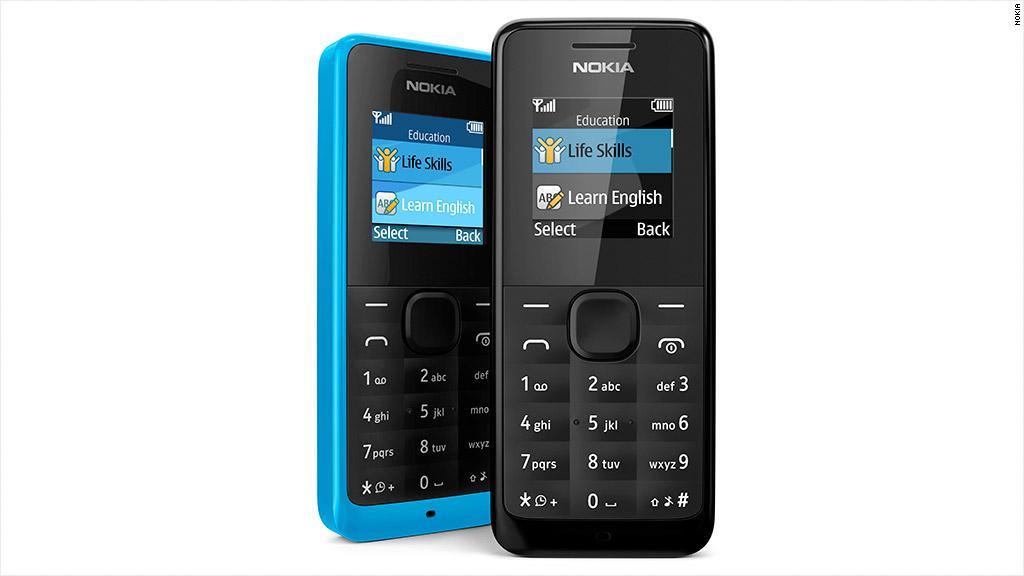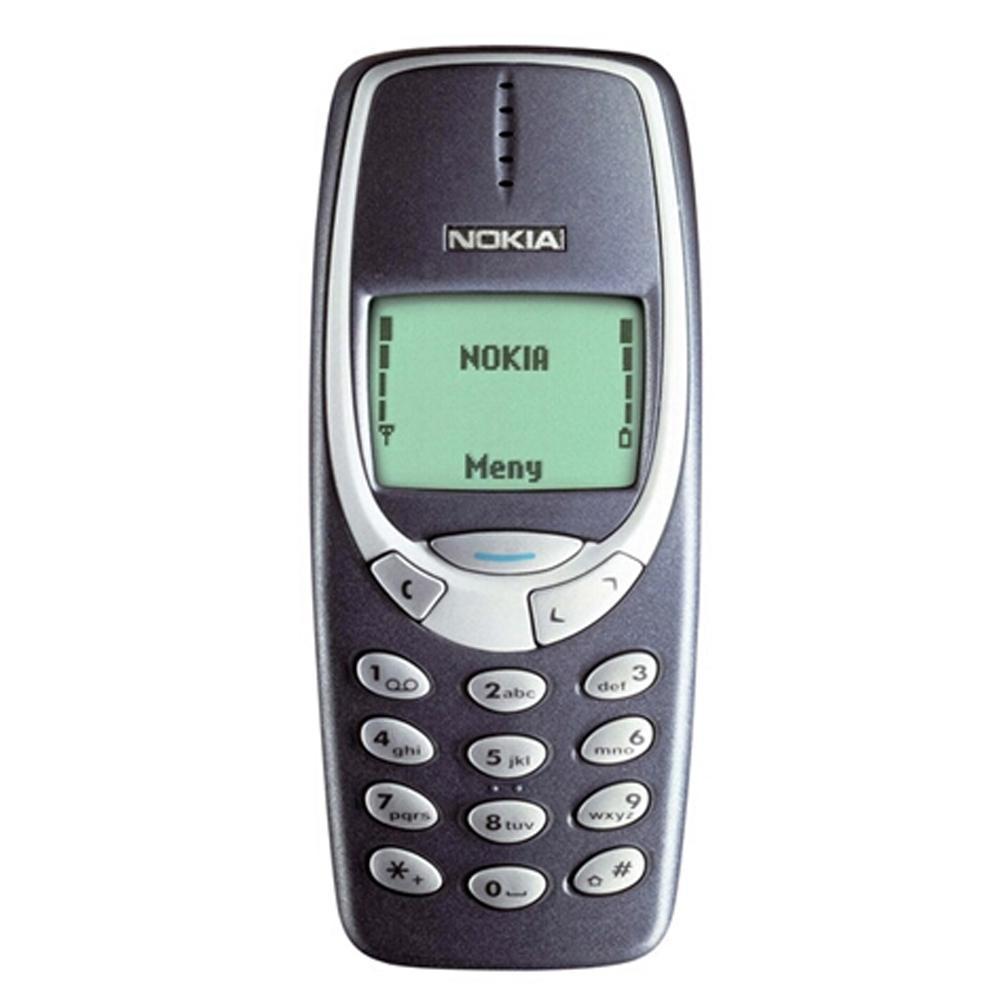The first image is the image on the left, the second image is the image on the right. Assess this claim about the two images: "The right image contains a single phone displayed upright, and the left image shows one phone overlapping another one that is not in side-view.". Correct or not? Answer yes or no. Yes. 